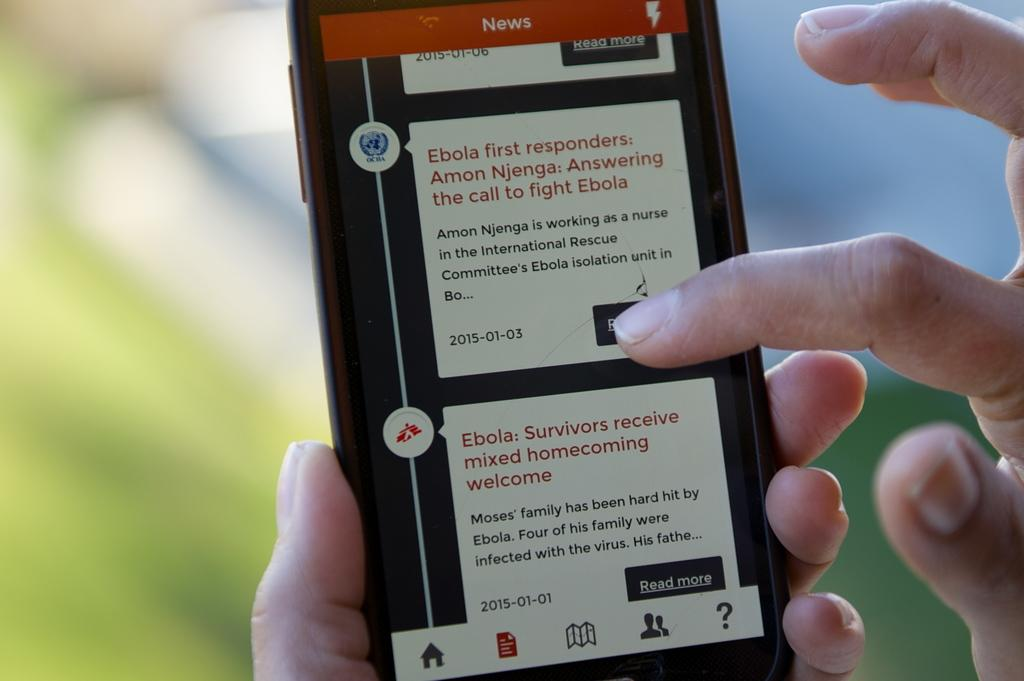<image>
Provide a brief description of the given image. Someone is reading the news about Ebola on their cell phone. 